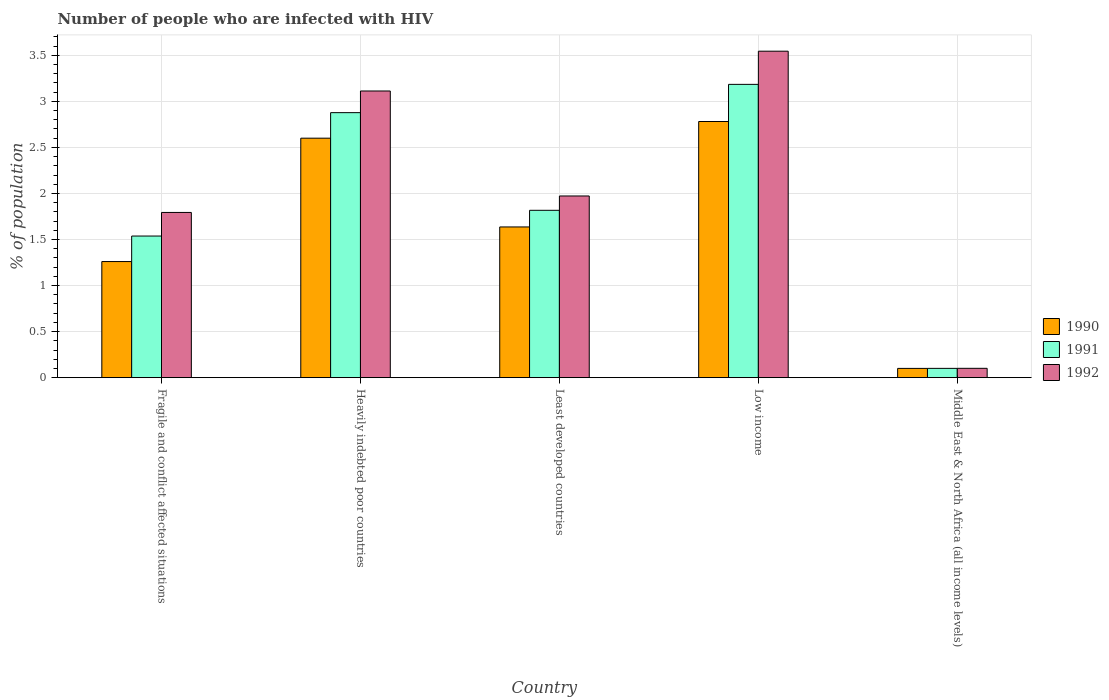How many different coloured bars are there?
Offer a very short reply. 3. How many groups of bars are there?
Make the answer very short. 5. Are the number of bars per tick equal to the number of legend labels?
Keep it short and to the point. Yes. Are the number of bars on each tick of the X-axis equal?
Your response must be concise. Yes. What is the label of the 4th group of bars from the left?
Provide a short and direct response. Low income. What is the percentage of HIV infected population in in 1990 in Least developed countries?
Offer a terse response. 1.64. Across all countries, what is the maximum percentage of HIV infected population in in 1992?
Make the answer very short. 3.54. Across all countries, what is the minimum percentage of HIV infected population in in 1991?
Provide a succinct answer. 0.1. In which country was the percentage of HIV infected population in in 1991 minimum?
Make the answer very short. Middle East & North Africa (all income levels). What is the total percentage of HIV infected population in in 1991 in the graph?
Provide a short and direct response. 9.52. What is the difference between the percentage of HIV infected population in in 1992 in Heavily indebted poor countries and that in Least developed countries?
Your response must be concise. 1.14. What is the difference between the percentage of HIV infected population in in 1992 in Fragile and conflict affected situations and the percentage of HIV infected population in in 1990 in Heavily indebted poor countries?
Offer a terse response. -0.81. What is the average percentage of HIV infected population in in 1992 per country?
Offer a very short reply. 2.1. What is the difference between the percentage of HIV infected population in of/in 1992 and percentage of HIV infected population in of/in 1990 in Low income?
Give a very brief answer. 0.76. In how many countries, is the percentage of HIV infected population in in 1991 greater than 3.3 %?
Provide a succinct answer. 0. What is the ratio of the percentage of HIV infected population in in 1990 in Heavily indebted poor countries to that in Middle East & North Africa (all income levels)?
Provide a short and direct response. 25.85. Is the percentage of HIV infected population in in 1992 in Fragile and conflict affected situations less than that in Heavily indebted poor countries?
Provide a short and direct response. Yes. What is the difference between the highest and the second highest percentage of HIV infected population in in 1992?
Make the answer very short. 1.14. What is the difference between the highest and the lowest percentage of HIV infected population in in 1991?
Your response must be concise. 3.08. In how many countries, is the percentage of HIV infected population in in 1991 greater than the average percentage of HIV infected population in in 1991 taken over all countries?
Keep it short and to the point. 2. Is the sum of the percentage of HIV infected population in in 1992 in Heavily indebted poor countries and Least developed countries greater than the maximum percentage of HIV infected population in in 1991 across all countries?
Keep it short and to the point. Yes. What does the 1st bar from the left in Low income represents?
Ensure brevity in your answer.  1990. What does the 1st bar from the right in Least developed countries represents?
Provide a succinct answer. 1992. Are all the bars in the graph horizontal?
Your answer should be very brief. No. How many countries are there in the graph?
Make the answer very short. 5. Does the graph contain any zero values?
Your answer should be compact. No. Where does the legend appear in the graph?
Provide a succinct answer. Center right. What is the title of the graph?
Keep it short and to the point. Number of people who are infected with HIV. Does "2012" appear as one of the legend labels in the graph?
Make the answer very short. No. What is the label or title of the Y-axis?
Ensure brevity in your answer.  % of population. What is the % of population in 1990 in Fragile and conflict affected situations?
Give a very brief answer. 1.26. What is the % of population in 1991 in Fragile and conflict affected situations?
Provide a short and direct response. 1.54. What is the % of population in 1992 in Fragile and conflict affected situations?
Make the answer very short. 1.79. What is the % of population in 1990 in Heavily indebted poor countries?
Give a very brief answer. 2.6. What is the % of population of 1991 in Heavily indebted poor countries?
Keep it short and to the point. 2.88. What is the % of population in 1992 in Heavily indebted poor countries?
Your answer should be compact. 3.11. What is the % of population in 1990 in Least developed countries?
Offer a terse response. 1.64. What is the % of population in 1991 in Least developed countries?
Provide a succinct answer. 1.82. What is the % of population in 1992 in Least developed countries?
Offer a very short reply. 1.97. What is the % of population in 1990 in Low income?
Keep it short and to the point. 2.78. What is the % of population of 1991 in Low income?
Make the answer very short. 3.18. What is the % of population of 1992 in Low income?
Offer a very short reply. 3.54. What is the % of population in 1990 in Middle East & North Africa (all income levels)?
Your answer should be compact. 0.1. What is the % of population in 1991 in Middle East & North Africa (all income levels)?
Provide a succinct answer. 0.1. What is the % of population of 1992 in Middle East & North Africa (all income levels)?
Your answer should be very brief. 0.1. Across all countries, what is the maximum % of population in 1990?
Your answer should be very brief. 2.78. Across all countries, what is the maximum % of population of 1991?
Ensure brevity in your answer.  3.18. Across all countries, what is the maximum % of population in 1992?
Offer a very short reply. 3.54. Across all countries, what is the minimum % of population of 1990?
Offer a very short reply. 0.1. Across all countries, what is the minimum % of population in 1991?
Make the answer very short. 0.1. Across all countries, what is the minimum % of population in 1992?
Make the answer very short. 0.1. What is the total % of population in 1990 in the graph?
Your response must be concise. 8.38. What is the total % of population of 1991 in the graph?
Provide a short and direct response. 9.52. What is the total % of population of 1992 in the graph?
Ensure brevity in your answer.  10.52. What is the difference between the % of population in 1990 in Fragile and conflict affected situations and that in Heavily indebted poor countries?
Provide a short and direct response. -1.34. What is the difference between the % of population of 1991 in Fragile and conflict affected situations and that in Heavily indebted poor countries?
Make the answer very short. -1.34. What is the difference between the % of population of 1992 in Fragile and conflict affected situations and that in Heavily indebted poor countries?
Provide a succinct answer. -1.32. What is the difference between the % of population in 1990 in Fragile and conflict affected situations and that in Least developed countries?
Ensure brevity in your answer.  -0.38. What is the difference between the % of population of 1991 in Fragile and conflict affected situations and that in Least developed countries?
Your answer should be very brief. -0.28. What is the difference between the % of population in 1992 in Fragile and conflict affected situations and that in Least developed countries?
Give a very brief answer. -0.18. What is the difference between the % of population in 1990 in Fragile and conflict affected situations and that in Low income?
Give a very brief answer. -1.52. What is the difference between the % of population of 1991 in Fragile and conflict affected situations and that in Low income?
Offer a very short reply. -1.65. What is the difference between the % of population in 1992 in Fragile and conflict affected situations and that in Low income?
Your response must be concise. -1.75. What is the difference between the % of population in 1990 in Fragile and conflict affected situations and that in Middle East & North Africa (all income levels)?
Give a very brief answer. 1.16. What is the difference between the % of population of 1991 in Fragile and conflict affected situations and that in Middle East & North Africa (all income levels)?
Give a very brief answer. 1.44. What is the difference between the % of population in 1992 in Fragile and conflict affected situations and that in Middle East & North Africa (all income levels)?
Your answer should be very brief. 1.69. What is the difference between the % of population in 1990 in Heavily indebted poor countries and that in Least developed countries?
Make the answer very short. 0.96. What is the difference between the % of population of 1991 in Heavily indebted poor countries and that in Least developed countries?
Your response must be concise. 1.06. What is the difference between the % of population in 1992 in Heavily indebted poor countries and that in Least developed countries?
Your response must be concise. 1.14. What is the difference between the % of population in 1990 in Heavily indebted poor countries and that in Low income?
Your answer should be compact. -0.18. What is the difference between the % of population of 1991 in Heavily indebted poor countries and that in Low income?
Offer a terse response. -0.31. What is the difference between the % of population of 1992 in Heavily indebted poor countries and that in Low income?
Provide a succinct answer. -0.43. What is the difference between the % of population of 1990 in Heavily indebted poor countries and that in Middle East & North Africa (all income levels)?
Offer a terse response. 2.5. What is the difference between the % of population of 1991 in Heavily indebted poor countries and that in Middle East & North Africa (all income levels)?
Your response must be concise. 2.78. What is the difference between the % of population in 1992 in Heavily indebted poor countries and that in Middle East & North Africa (all income levels)?
Your answer should be compact. 3.01. What is the difference between the % of population of 1990 in Least developed countries and that in Low income?
Provide a short and direct response. -1.14. What is the difference between the % of population of 1991 in Least developed countries and that in Low income?
Your answer should be very brief. -1.37. What is the difference between the % of population in 1992 in Least developed countries and that in Low income?
Offer a very short reply. -1.57. What is the difference between the % of population of 1990 in Least developed countries and that in Middle East & North Africa (all income levels)?
Make the answer very short. 1.54. What is the difference between the % of population of 1991 in Least developed countries and that in Middle East & North Africa (all income levels)?
Your answer should be very brief. 1.72. What is the difference between the % of population in 1992 in Least developed countries and that in Middle East & North Africa (all income levels)?
Ensure brevity in your answer.  1.87. What is the difference between the % of population in 1990 in Low income and that in Middle East & North Africa (all income levels)?
Your response must be concise. 2.68. What is the difference between the % of population in 1991 in Low income and that in Middle East & North Africa (all income levels)?
Offer a very short reply. 3.08. What is the difference between the % of population of 1992 in Low income and that in Middle East & North Africa (all income levels)?
Provide a succinct answer. 3.44. What is the difference between the % of population of 1990 in Fragile and conflict affected situations and the % of population of 1991 in Heavily indebted poor countries?
Your answer should be compact. -1.62. What is the difference between the % of population of 1990 in Fragile and conflict affected situations and the % of population of 1992 in Heavily indebted poor countries?
Offer a terse response. -1.85. What is the difference between the % of population of 1991 in Fragile and conflict affected situations and the % of population of 1992 in Heavily indebted poor countries?
Offer a terse response. -1.57. What is the difference between the % of population of 1990 in Fragile and conflict affected situations and the % of population of 1991 in Least developed countries?
Your response must be concise. -0.56. What is the difference between the % of population in 1990 in Fragile and conflict affected situations and the % of population in 1992 in Least developed countries?
Your response must be concise. -0.71. What is the difference between the % of population in 1991 in Fragile and conflict affected situations and the % of population in 1992 in Least developed countries?
Provide a short and direct response. -0.43. What is the difference between the % of population in 1990 in Fragile and conflict affected situations and the % of population in 1991 in Low income?
Your response must be concise. -1.92. What is the difference between the % of population of 1990 in Fragile and conflict affected situations and the % of population of 1992 in Low income?
Your response must be concise. -2.28. What is the difference between the % of population of 1991 in Fragile and conflict affected situations and the % of population of 1992 in Low income?
Provide a succinct answer. -2.01. What is the difference between the % of population of 1990 in Fragile and conflict affected situations and the % of population of 1991 in Middle East & North Africa (all income levels)?
Ensure brevity in your answer.  1.16. What is the difference between the % of population of 1990 in Fragile and conflict affected situations and the % of population of 1992 in Middle East & North Africa (all income levels)?
Give a very brief answer. 1.16. What is the difference between the % of population of 1991 in Fragile and conflict affected situations and the % of population of 1992 in Middle East & North Africa (all income levels)?
Keep it short and to the point. 1.44. What is the difference between the % of population in 1990 in Heavily indebted poor countries and the % of population in 1991 in Least developed countries?
Your answer should be compact. 0.78. What is the difference between the % of population in 1990 in Heavily indebted poor countries and the % of population in 1992 in Least developed countries?
Offer a terse response. 0.63. What is the difference between the % of population in 1991 in Heavily indebted poor countries and the % of population in 1992 in Least developed countries?
Ensure brevity in your answer.  0.9. What is the difference between the % of population of 1990 in Heavily indebted poor countries and the % of population of 1991 in Low income?
Provide a short and direct response. -0.58. What is the difference between the % of population of 1990 in Heavily indebted poor countries and the % of population of 1992 in Low income?
Give a very brief answer. -0.94. What is the difference between the % of population of 1991 in Heavily indebted poor countries and the % of population of 1992 in Low income?
Offer a very short reply. -0.67. What is the difference between the % of population of 1990 in Heavily indebted poor countries and the % of population of 1991 in Middle East & North Africa (all income levels)?
Keep it short and to the point. 2.5. What is the difference between the % of population in 1990 in Heavily indebted poor countries and the % of population in 1992 in Middle East & North Africa (all income levels)?
Your answer should be very brief. 2.5. What is the difference between the % of population of 1991 in Heavily indebted poor countries and the % of population of 1992 in Middle East & North Africa (all income levels)?
Your answer should be compact. 2.78. What is the difference between the % of population of 1990 in Least developed countries and the % of population of 1991 in Low income?
Your response must be concise. -1.55. What is the difference between the % of population in 1990 in Least developed countries and the % of population in 1992 in Low income?
Provide a succinct answer. -1.91. What is the difference between the % of population of 1991 in Least developed countries and the % of population of 1992 in Low income?
Your answer should be very brief. -1.73. What is the difference between the % of population in 1990 in Least developed countries and the % of population in 1991 in Middle East & North Africa (all income levels)?
Your answer should be compact. 1.54. What is the difference between the % of population in 1990 in Least developed countries and the % of population in 1992 in Middle East & North Africa (all income levels)?
Give a very brief answer. 1.53. What is the difference between the % of population of 1991 in Least developed countries and the % of population of 1992 in Middle East & North Africa (all income levels)?
Ensure brevity in your answer.  1.72. What is the difference between the % of population in 1990 in Low income and the % of population in 1991 in Middle East & North Africa (all income levels)?
Offer a terse response. 2.68. What is the difference between the % of population of 1990 in Low income and the % of population of 1992 in Middle East & North Africa (all income levels)?
Offer a very short reply. 2.68. What is the difference between the % of population of 1991 in Low income and the % of population of 1992 in Middle East & North Africa (all income levels)?
Offer a very short reply. 3.08. What is the average % of population in 1990 per country?
Your answer should be very brief. 1.68. What is the average % of population in 1991 per country?
Keep it short and to the point. 1.9. What is the average % of population in 1992 per country?
Your answer should be compact. 2.1. What is the difference between the % of population in 1990 and % of population in 1991 in Fragile and conflict affected situations?
Your response must be concise. -0.28. What is the difference between the % of population of 1990 and % of population of 1992 in Fragile and conflict affected situations?
Offer a terse response. -0.53. What is the difference between the % of population in 1991 and % of population in 1992 in Fragile and conflict affected situations?
Make the answer very short. -0.26. What is the difference between the % of population of 1990 and % of population of 1991 in Heavily indebted poor countries?
Ensure brevity in your answer.  -0.28. What is the difference between the % of population of 1990 and % of population of 1992 in Heavily indebted poor countries?
Provide a succinct answer. -0.51. What is the difference between the % of population of 1991 and % of population of 1992 in Heavily indebted poor countries?
Make the answer very short. -0.23. What is the difference between the % of population in 1990 and % of population in 1991 in Least developed countries?
Offer a terse response. -0.18. What is the difference between the % of population of 1990 and % of population of 1992 in Least developed countries?
Offer a very short reply. -0.34. What is the difference between the % of population of 1991 and % of population of 1992 in Least developed countries?
Keep it short and to the point. -0.16. What is the difference between the % of population in 1990 and % of population in 1991 in Low income?
Keep it short and to the point. -0.4. What is the difference between the % of population in 1990 and % of population in 1992 in Low income?
Keep it short and to the point. -0.76. What is the difference between the % of population in 1991 and % of population in 1992 in Low income?
Your answer should be compact. -0.36. What is the difference between the % of population in 1990 and % of population in 1991 in Middle East & North Africa (all income levels)?
Make the answer very short. -0. What is the difference between the % of population in 1990 and % of population in 1992 in Middle East & North Africa (all income levels)?
Offer a very short reply. -0. What is the difference between the % of population of 1991 and % of population of 1992 in Middle East & North Africa (all income levels)?
Ensure brevity in your answer.  -0. What is the ratio of the % of population of 1990 in Fragile and conflict affected situations to that in Heavily indebted poor countries?
Provide a short and direct response. 0.48. What is the ratio of the % of population of 1991 in Fragile and conflict affected situations to that in Heavily indebted poor countries?
Offer a very short reply. 0.53. What is the ratio of the % of population of 1992 in Fragile and conflict affected situations to that in Heavily indebted poor countries?
Offer a very short reply. 0.58. What is the ratio of the % of population of 1990 in Fragile and conflict affected situations to that in Least developed countries?
Your answer should be compact. 0.77. What is the ratio of the % of population of 1991 in Fragile and conflict affected situations to that in Least developed countries?
Offer a very short reply. 0.85. What is the ratio of the % of population of 1992 in Fragile and conflict affected situations to that in Least developed countries?
Provide a succinct answer. 0.91. What is the ratio of the % of population in 1990 in Fragile and conflict affected situations to that in Low income?
Your response must be concise. 0.45. What is the ratio of the % of population in 1991 in Fragile and conflict affected situations to that in Low income?
Ensure brevity in your answer.  0.48. What is the ratio of the % of population of 1992 in Fragile and conflict affected situations to that in Low income?
Your answer should be compact. 0.51. What is the ratio of the % of population in 1990 in Fragile and conflict affected situations to that in Middle East & North Africa (all income levels)?
Your response must be concise. 12.53. What is the ratio of the % of population of 1991 in Fragile and conflict affected situations to that in Middle East & North Africa (all income levels)?
Keep it short and to the point. 15.24. What is the ratio of the % of population of 1992 in Fragile and conflict affected situations to that in Middle East & North Africa (all income levels)?
Your answer should be very brief. 17.67. What is the ratio of the % of population in 1990 in Heavily indebted poor countries to that in Least developed countries?
Your answer should be very brief. 1.59. What is the ratio of the % of population in 1991 in Heavily indebted poor countries to that in Least developed countries?
Give a very brief answer. 1.58. What is the ratio of the % of population of 1992 in Heavily indebted poor countries to that in Least developed countries?
Your answer should be very brief. 1.58. What is the ratio of the % of population in 1990 in Heavily indebted poor countries to that in Low income?
Offer a terse response. 0.94. What is the ratio of the % of population in 1991 in Heavily indebted poor countries to that in Low income?
Your response must be concise. 0.9. What is the ratio of the % of population in 1992 in Heavily indebted poor countries to that in Low income?
Ensure brevity in your answer.  0.88. What is the ratio of the % of population in 1990 in Heavily indebted poor countries to that in Middle East & North Africa (all income levels)?
Keep it short and to the point. 25.85. What is the ratio of the % of population in 1991 in Heavily indebted poor countries to that in Middle East & North Africa (all income levels)?
Keep it short and to the point. 28.52. What is the ratio of the % of population in 1992 in Heavily indebted poor countries to that in Middle East & North Africa (all income levels)?
Your response must be concise. 30.66. What is the ratio of the % of population in 1990 in Least developed countries to that in Low income?
Make the answer very short. 0.59. What is the ratio of the % of population in 1991 in Least developed countries to that in Low income?
Make the answer very short. 0.57. What is the ratio of the % of population of 1992 in Least developed countries to that in Low income?
Ensure brevity in your answer.  0.56. What is the ratio of the % of population of 1990 in Least developed countries to that in Middle East & North Africa (all income levels)?
Your answer should be compact. 16.27. What is the ratio of the % of population of 1991 in Least developed countries to that in Middle East & North Africa (all income levels)?
Offer a terse response. 18.01. What is the ratio of the % of population of 1992 in Least developed countries to that in Middle East & North Africa (all income levels)?
Give a very brief answer. 19.43. What is the ratio of the % of population of 1990 in Low income to that in Middle East & North Africa (all income levels)?
Keep it short and to the point. 27.64. What is the ratio of the % of population of 1991 in Low income to that in Middle East & North Africa (all income levels)?
Your answer should be very brief. 31.56. What is the ratio of the % of population in 1992 in Low income to that in Middle East & North Africa (all income levels)?
Offer a very short reply. 34.92. What is the difference between the highest and the second highest % of population in 1990?
Make the answer very short. 0.18. What is the difference between the highest and the second highest % of population of 1991?
Your answer should be very brief. 0.31. What is the difference between the highest and the second highest % of population in 1992?
Give a very brief answer. 0.43. What is the difference between the highest and the lowest % of population of 1990?
Your answer should be very brief. 2.68. What is the difference between the highest and the lowest % of population in 1991?
Offer a very short reply. 3.08. What is the difference between the highest and the lowest % of population in 1992?
Provide a succinct answer. 3.44. 